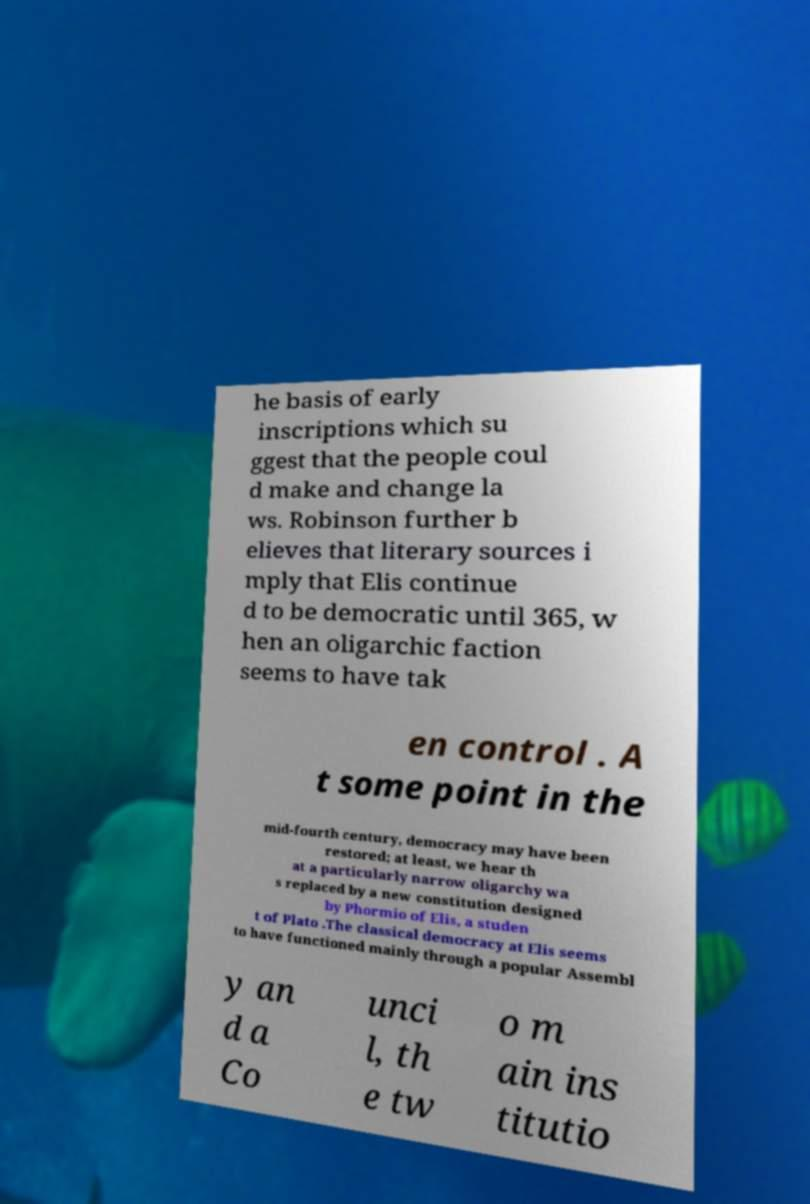Can you read and provide the text displayed in the image?This photo seems to have some interesting text. Can you extract and type it out for me? he basis of early inscriptions which su ggest that the people coul d make and change la ws. Robinson further b elieves that literary sources i mply that Elis continue d to be democratic until 365, w hen an oligarchic faction seems to have tak en control . A t some point in the mid-fourth century, democracy may have been restored; at least, we hear th at a particularly narrow oligarchy wa s replaced by a new constitution designed by Phormio of Elis, a studen t of Plato .The classical democracy at Elis seems to have functioned mainly through a popular Assembl y an d a Co unci l, th e tw o m ain ins titutio 